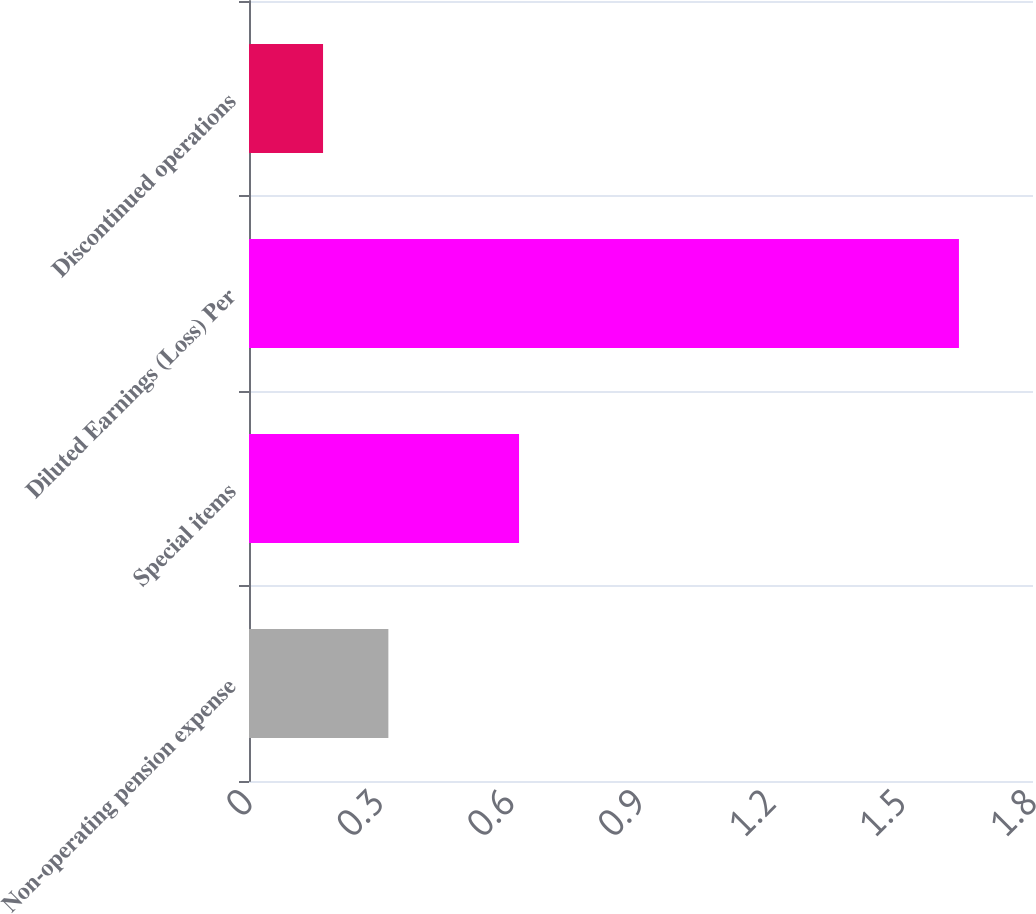Convert chart to OTSL. <chart><loc_0><loc_0><loc_500><loc_500><bar_chart><fcel>Non-operating pension expense<fcel>Special items<fcel>Diluted Earnings (Loss) Per<fcel>Discontinued operations<nl><fcel>0.32<fcel>0.62<fcel>1.63<fcel>0.17<nl></chart> 